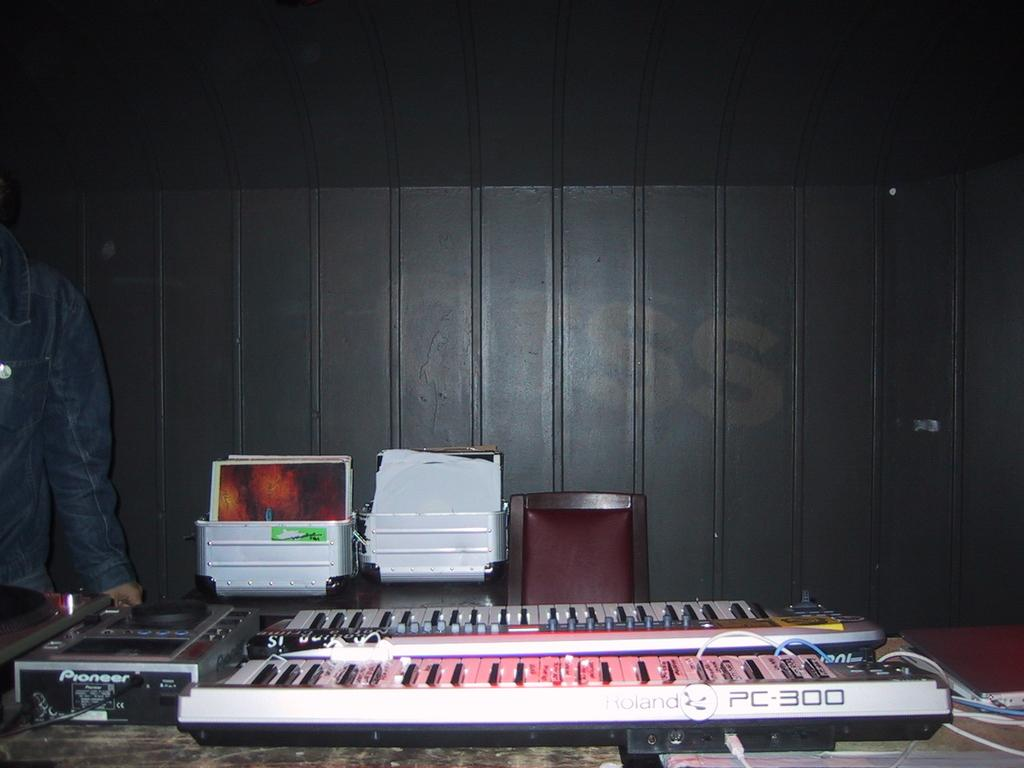How many pianos are visible in the image? There are two pianos in the image. What else can be seen on the table besides the pianos? There are other objects on the table. Can you describe the person in the image? There is a person standing in the left corner of the image. What type of food is being prepared on the pianos in the image? There is no food or cooking activity visible in the image; the main subjects are the two pianos. 